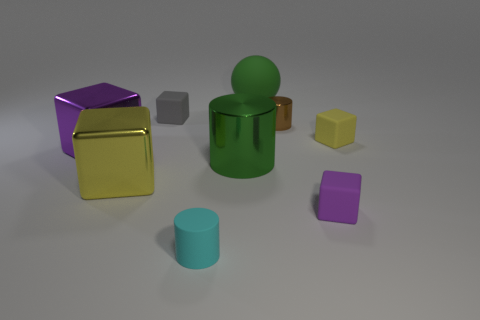There is a shiny cylinder that is in front of the tiny yellow cube; how big is it? The cylinder appears to be medium-sized in comparison to the surrounding objects. Specifically, it's smaller than the green figure and the golden cube, but larger than the tiny yellow cube and the small purple cube next to it. 